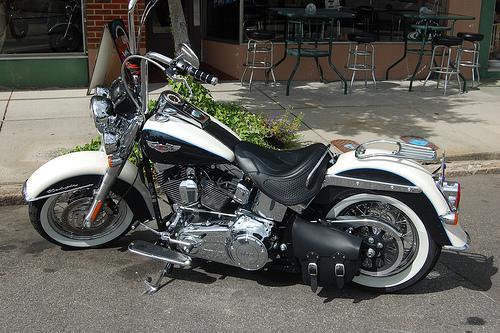How many motorcycles are in the picture?
Give a very brief answer. 1. How many dinosaurs are in the picture?
Give a very brief answer. 0. How many people sitting on the motorcycle?
Give a very brief answer. 0. How many tires does the motorcycle have?
Give a very brief answer. 2. How many stools adjacent to each other?
Give a very brief answer. 2. 